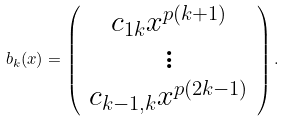Convert formula to latex. <formula><loc_0><loc_0><loc_500><loc_500>b _ { k } ( x ) = \left ( \begin{array} { c } c _ { 1 k } x ^ { p ( k + 1 ) } \\ \vdots \\ c _ { k - 1 , k } x ^ { p ( 2 k - 1 ) } \\ \end{array} \right ) .</formula> 